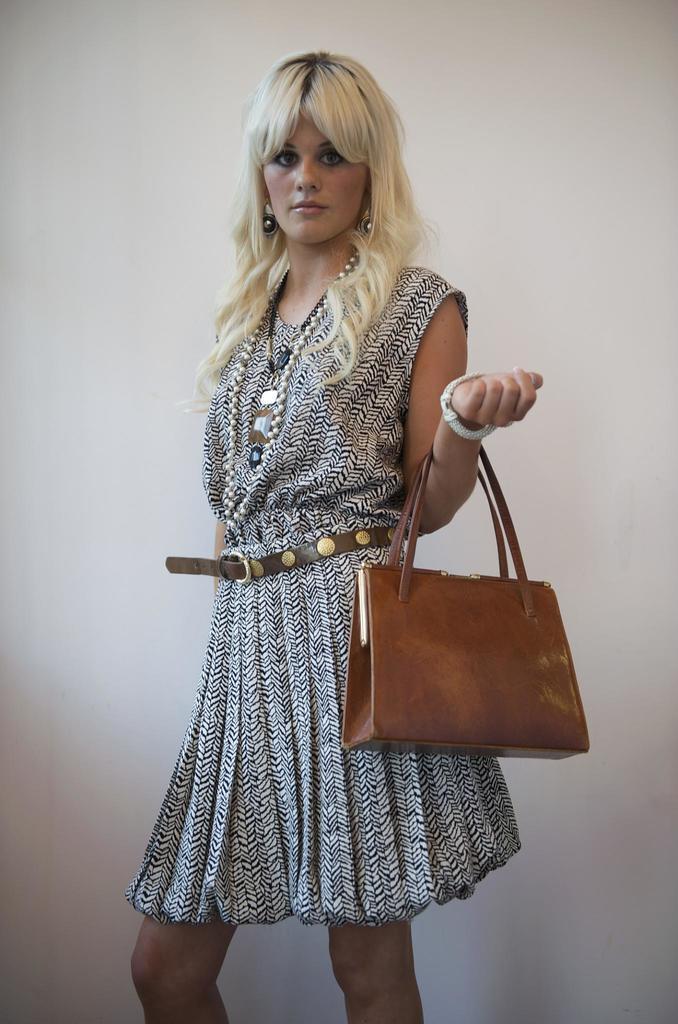Could you give a brief overview of what you see in this image? In the picture we can find woman holding a handbag and her hair is in white in colour and she is wearing a skirt with belt. 